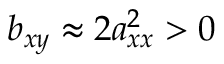<formula> <loc_0><loc_0><loc_500><loc_500>b _ { x y } \approx 2 a _ { x x } ^ { 2 } > 0</formula> 